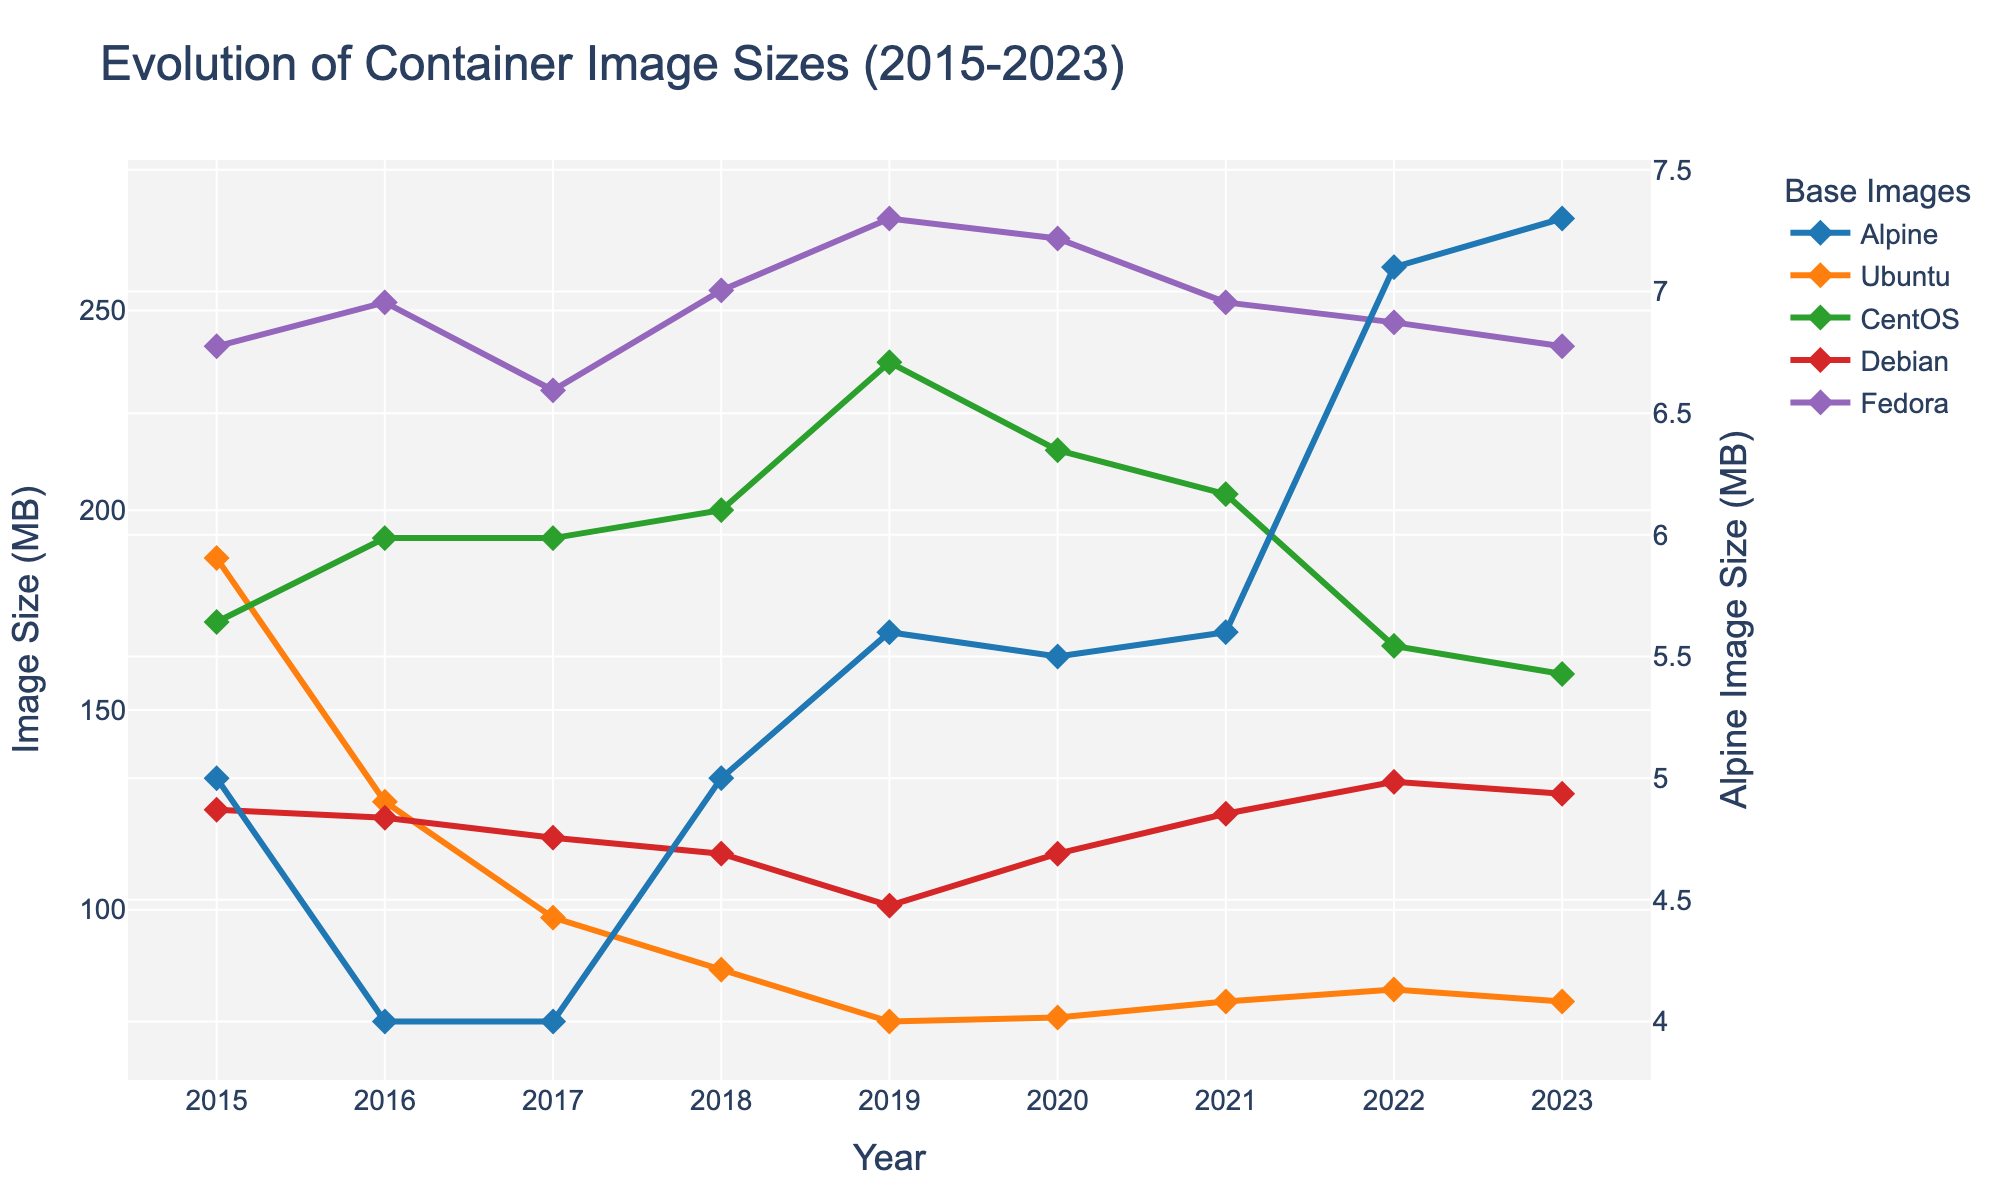Which base image had the smallest size in 2015? To find the smallest size for 2015, look at the values in the 2015 column. Alpine has the smallest value with 5 MB.
Answer: Alpine How did the size of the Ubuntu image change from 2015 to 2023? Subtract the size of the Ubuntu image in 2023 from its size in 2015: 188 MB - 77 MB = 111 MB. The size decreased by 111 MB.
Answer: Decreased by 111 MB Which base image had the largest size in 2020? To find the largest size for 2020, look at the values in the 2020 column. Fedora has the largest value with 268 MB.
Answer: Fedora What is the average size of the Debian image from 2015 to 2023? Add the sizes of the Debian image from each year and divide by the number of years: (125 + 123 + 118 + 114 + 101 + 114 + 124 + 132 + 129) / 9 ≈ 120.
Answer: 120 In what year did the CentOS image size peak? Look at the values for CentOS across all years. The peak size is 237 MB, which occurs in 2019.
Answer: 2019 Between Fedora and Debian images, which one saw a greater reduction in size from 2015 to 2023? Calculate the reduction for each: 
Fedora: 241 - 241 = 0 MB 
Debian: 125 - 129 =  -4 MB
Debian saw an increase of 4 MB, while Fedora saw no reduction.
Answer: Fedora Which base image remained relatively consistent in size over the years compared to others? Alpine remained relatively consistent with sizes ranging from 4 MB to 7.3 MB, whereas the other images exhibited larger fluctuations.
Answer: Alpine What was the trend for the Fedora image size from 2015 to 2023? Assess the yearly sizes for Fedora: increased initially from 241 MB in 2015 to 273 MB in 2019, then decreased steadily to 241 MB in 2023.
Answer: Initially increased, then decreased How many base images had a smaller size in 2023 compared to 2015? Compare the image sizes in 2023 and 2015:
- Alpine: increase (7.3 vs 5)
- Ubuntu: decrease (77 vs 188)
- CentOS: decrease (159 vs 172)
- Debian: increase (129 vs 125)
- Fedora: same (241 vs 241)
Two images (Ubuntu, CentOS) had a smaller size in 2023 compared to 2015.
Answer: 2 images 